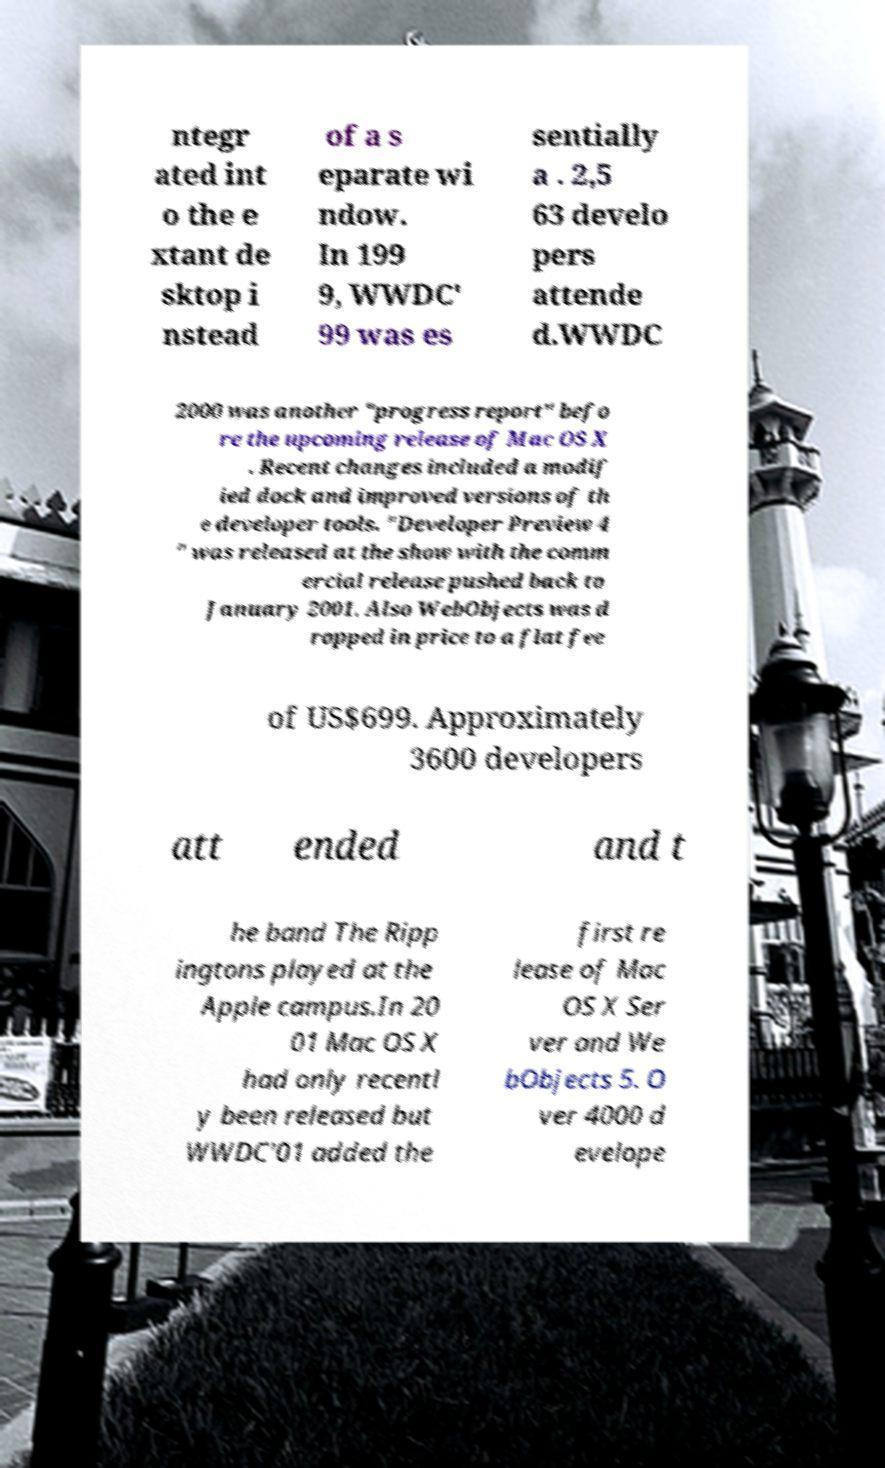Could you extract and type out the text from this image? ntegr ated int o the e xtant de sktop i nstead of a s eparate wi ndow. In 199 9, WWDC' 99 was es sentially a . 2,5 63 develo pers attende d.WWDC 2000 was another "progress report" befo re the upcoming release of Mac OS X . Recent changes included a modif ied dock and improved versions of th e developer tools. "Developer Preview 4 " was released at the show with the comm ercial release pushed back to January 2001. Also WebObjects was d ropped in price to a flat fee of US$699. Approximately 3600 developers att ended and t he band The Ripp ingtons played at the Apple campus.In 20 01 Mac OS X had only recentl y been released but WWDC'01 added the first re lease of Mac OS X Ser ver and We bObjects 5. O ver 4000 d evelope 